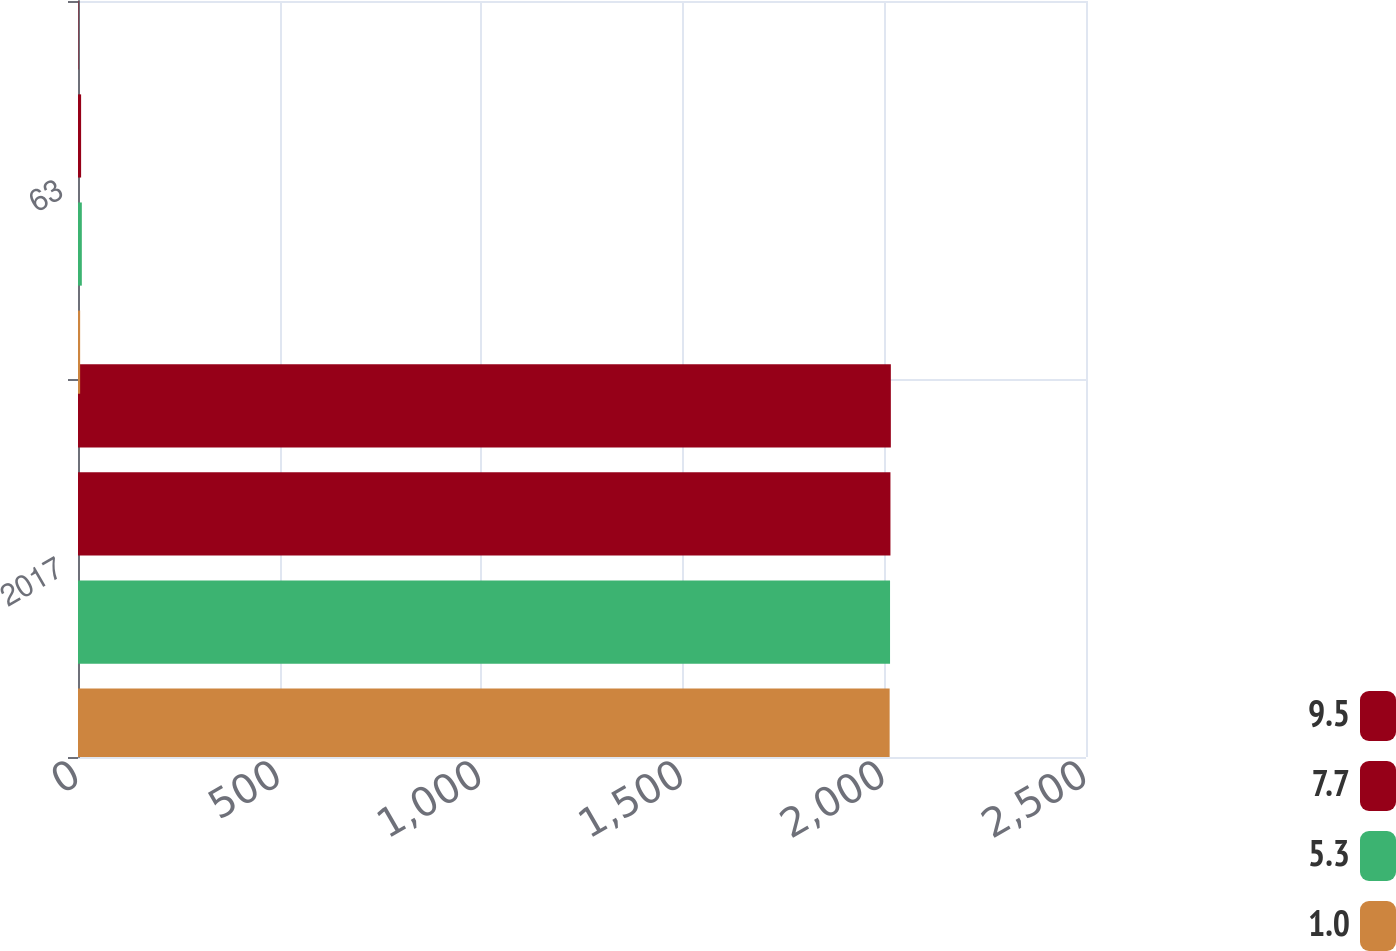Convert chart to OTSL. <chart><loc_0><loc_0><loc_500><loc_500><stacked_bar_chart><ecel><fcel>2017<fcel>63<nl><fcel>9.5<fcel>2016<fcel>1<nl><fcel>7.7<fcel>2015<fcel>7.7<nl><fcel>5.3<fcel>2014<fcel>9.5<nl><fcel>1<fcel>2013<fcel>5.3<nl></chart> 